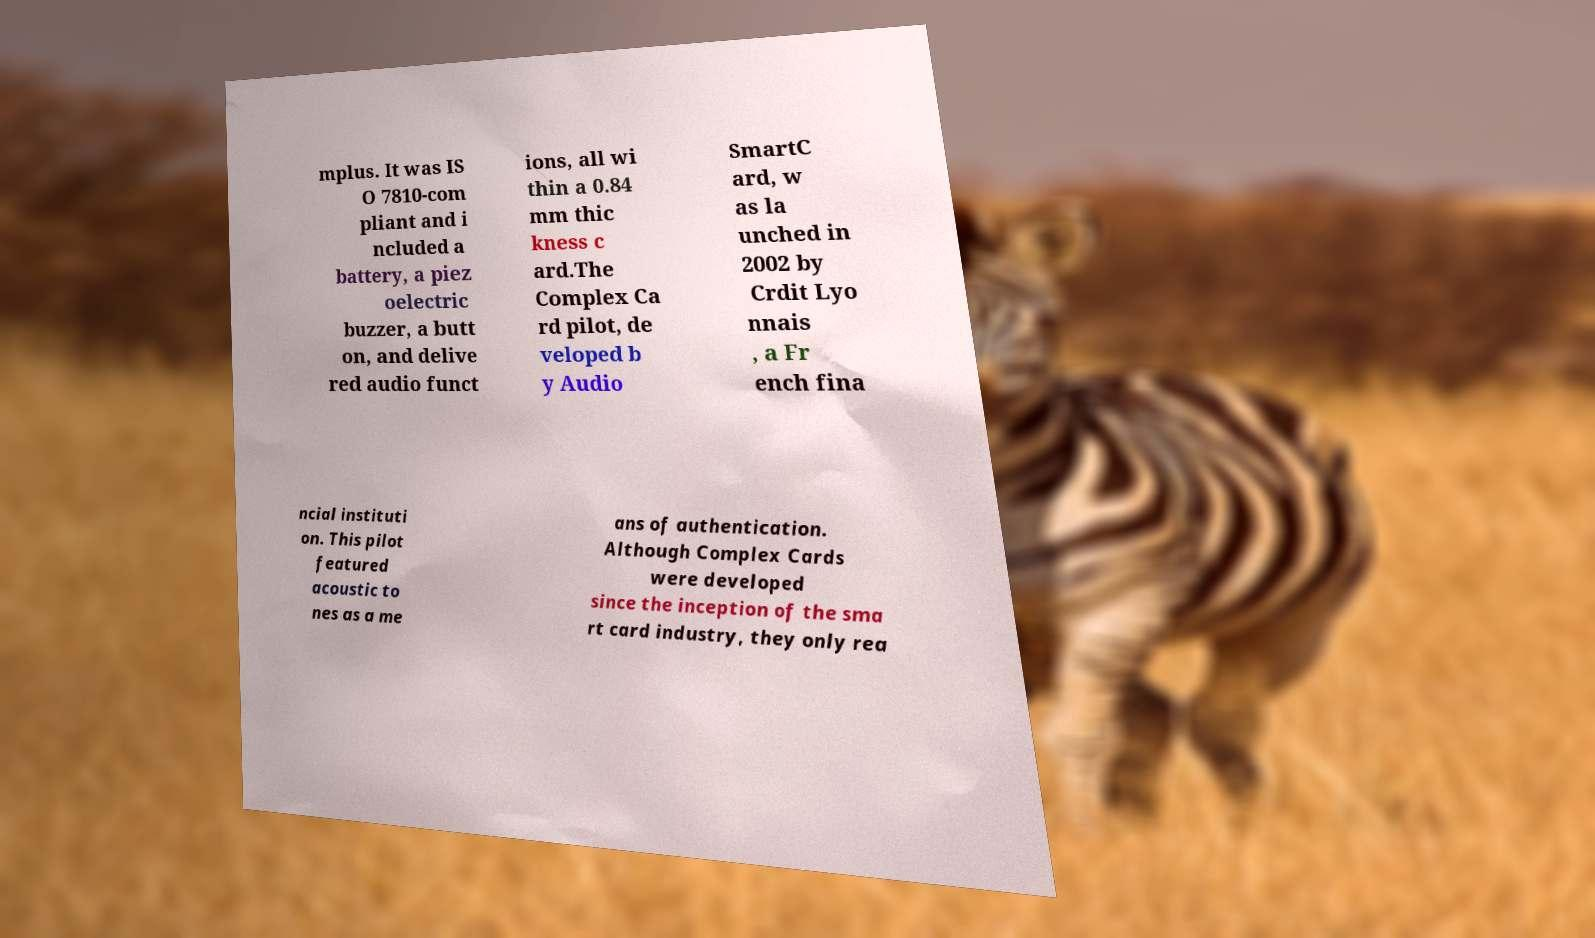Please read and relay the text visible in this image. What does it say? mplus. It was IS O 7810-com pliant and i ncluded a battery, a piez oelectric buzzer, a butt on, and delive red audio funct ions, all wi thin a 0.84 mm thic kness c ard.The Complex Ca rd pilot, de veloped b y Audio SmartC ard, w as la unched in 2002 by Crdit Lyo nnais , a Fr ench fina ncial instituti on. This pilot featured acoustic to nes as a me ans of authentication. Although Complex Cards were developed since the inception of the sma rt card industry, they only rea 